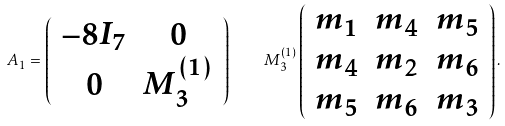Convert formula to latex. <formula><loc_0><loc_0><loc_500><loc_500>A _ { 1 } = \left ( \begin{array} { c c } - 8 I _ { 7 } & 0 \\ 0 & M ^ { ( 1 ) } _ { 3 } \\ \end{array} \right ) \quad M ^ { ( 1 ) } _ { 3 } \left ( \begin{array} { c c c } m _ { 1 } & m _ { 4 } & m _ { 5 } \\ m _ { 4 } & m _ { 2 } & m _ { 6 } \\ m _ { 5 } & m _ { 6 } & m _ { 3 } \\ \end{array} \right ) .</formula> 